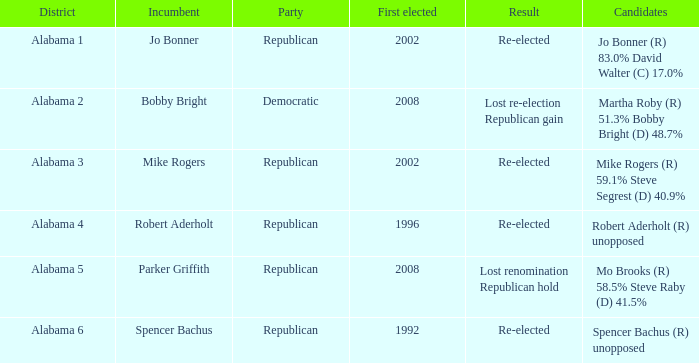Name the result for first elected being 1992 Re-elected. 